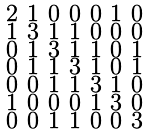<formula> <loc_0><loc_0><loc_500><loc_500>\begin{smallmatrix} 2 & 1 & 0 & 0 & 0 & 1 & 0 \\ 1 & 3 & 1 & 1 & 0 & 0 & 0 \\ 0 & 1 & 3 & 1 & 1 & 0 & 1 \\ 0 & 1 & 1 & 3 & 1 & 0 & 1 \\ 0 & 0 & 1 & 1 & 3 & 1 & 0 \\ 1 & 0 & 0 & 0 & 1 & 3 & 0 \\ 0 & 0 & 1 & 1 & 0 & 0 & 3 \end{smallmatrix}</formula> 